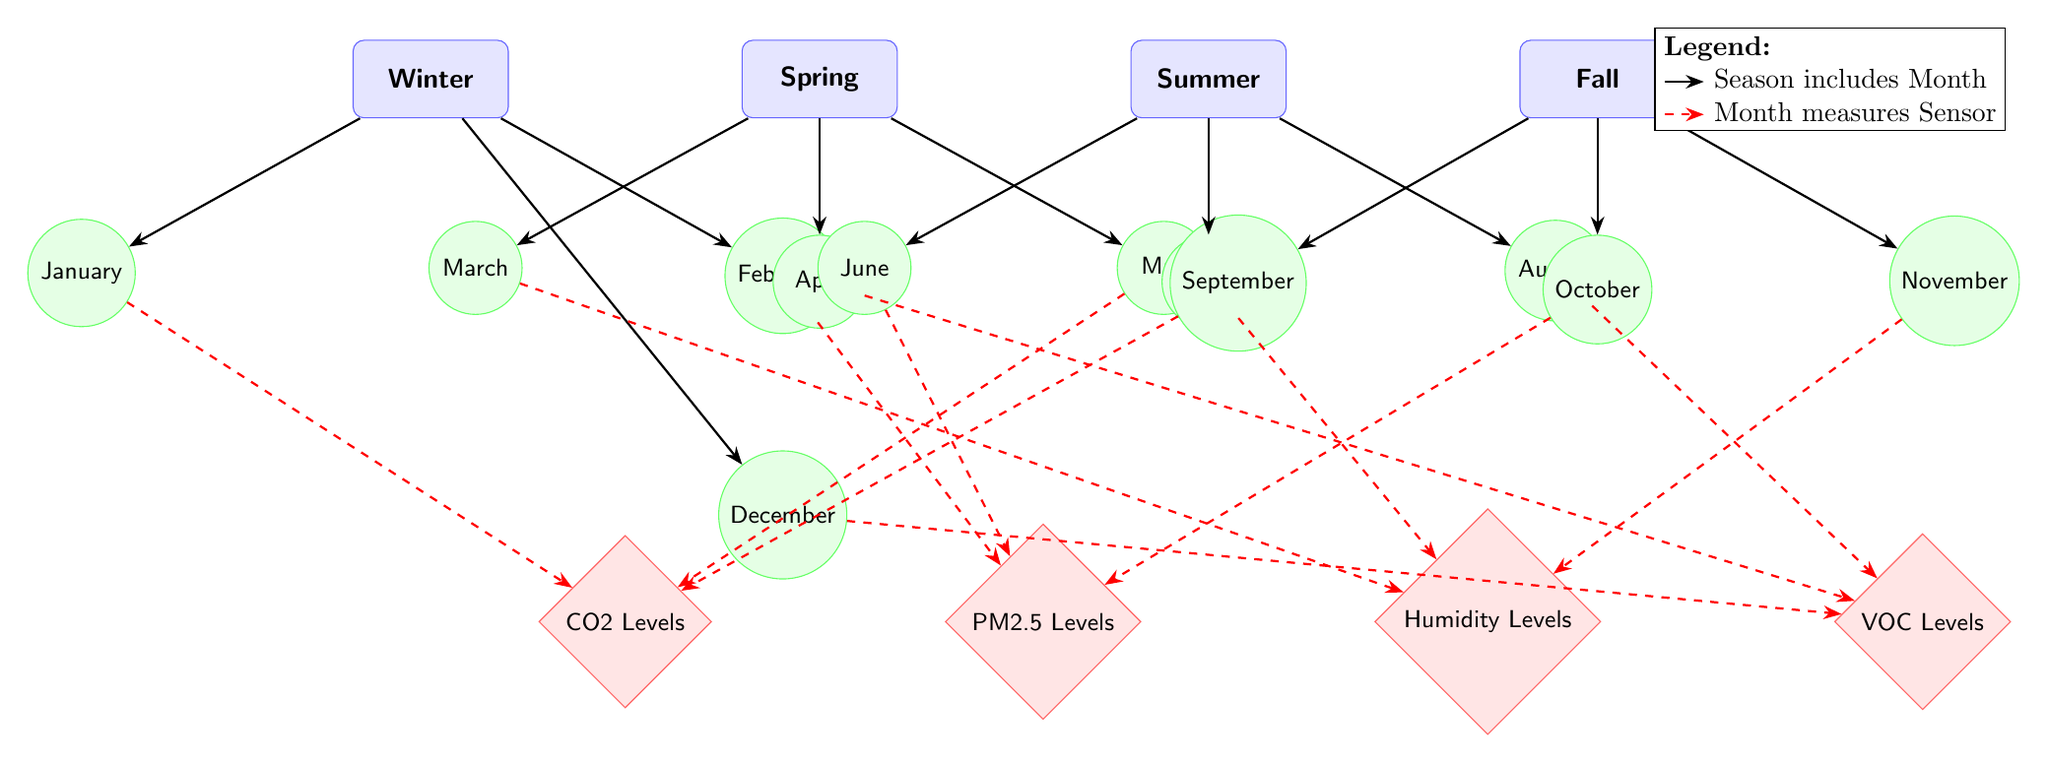What are the four seasons shown in the diagram? The diagram explicitly lists the four seasons: Winter, Spring, Summer, and Fall, arranged from left to right at the top.
Answer: Winter, Spring, Summer, Fall How many months are represented in the diagram? There are twelve months depicted in the diagram, each positioned below their corresponding season.
Answer: 12 Which month is associated with CO2 levels? The diagram shows that January and May are both associated with CO2 levels as indicated by the dashed red arrows connecting them to the CO2 sensor below.
Answer: January, May What is the connection between April and the sensor type? April connects to VOC Levels, as indicated by the dashed red arrow leading from April to the VOC sensor.
Answer: VOC Levels Which month is connected to humidity levels in summer? The month of July has a dashed red arrow leading to the humidity sensor, indicating a connection to humidity levels specifically in the summer.
Answer: July Which season connects with February? February is connected to the Winter season, as represented by the arrow leading from Winter to February positioned above it.
Answer: Winter Which season corresponds to the months of August and September? The month of August corresponds to Summer, while September corresponds to Fall, as indicated by their placements under the respective seasons.
Answer: Summer, Fall What do the dashed red arrows represent in the diagram? The dashed red arrows indicate the relationship between each month and its associated sensor measurements, such as CO2 levels, PM2.5 levels, humidity levels, and VOC levels.
Answer: Sensor measurements 